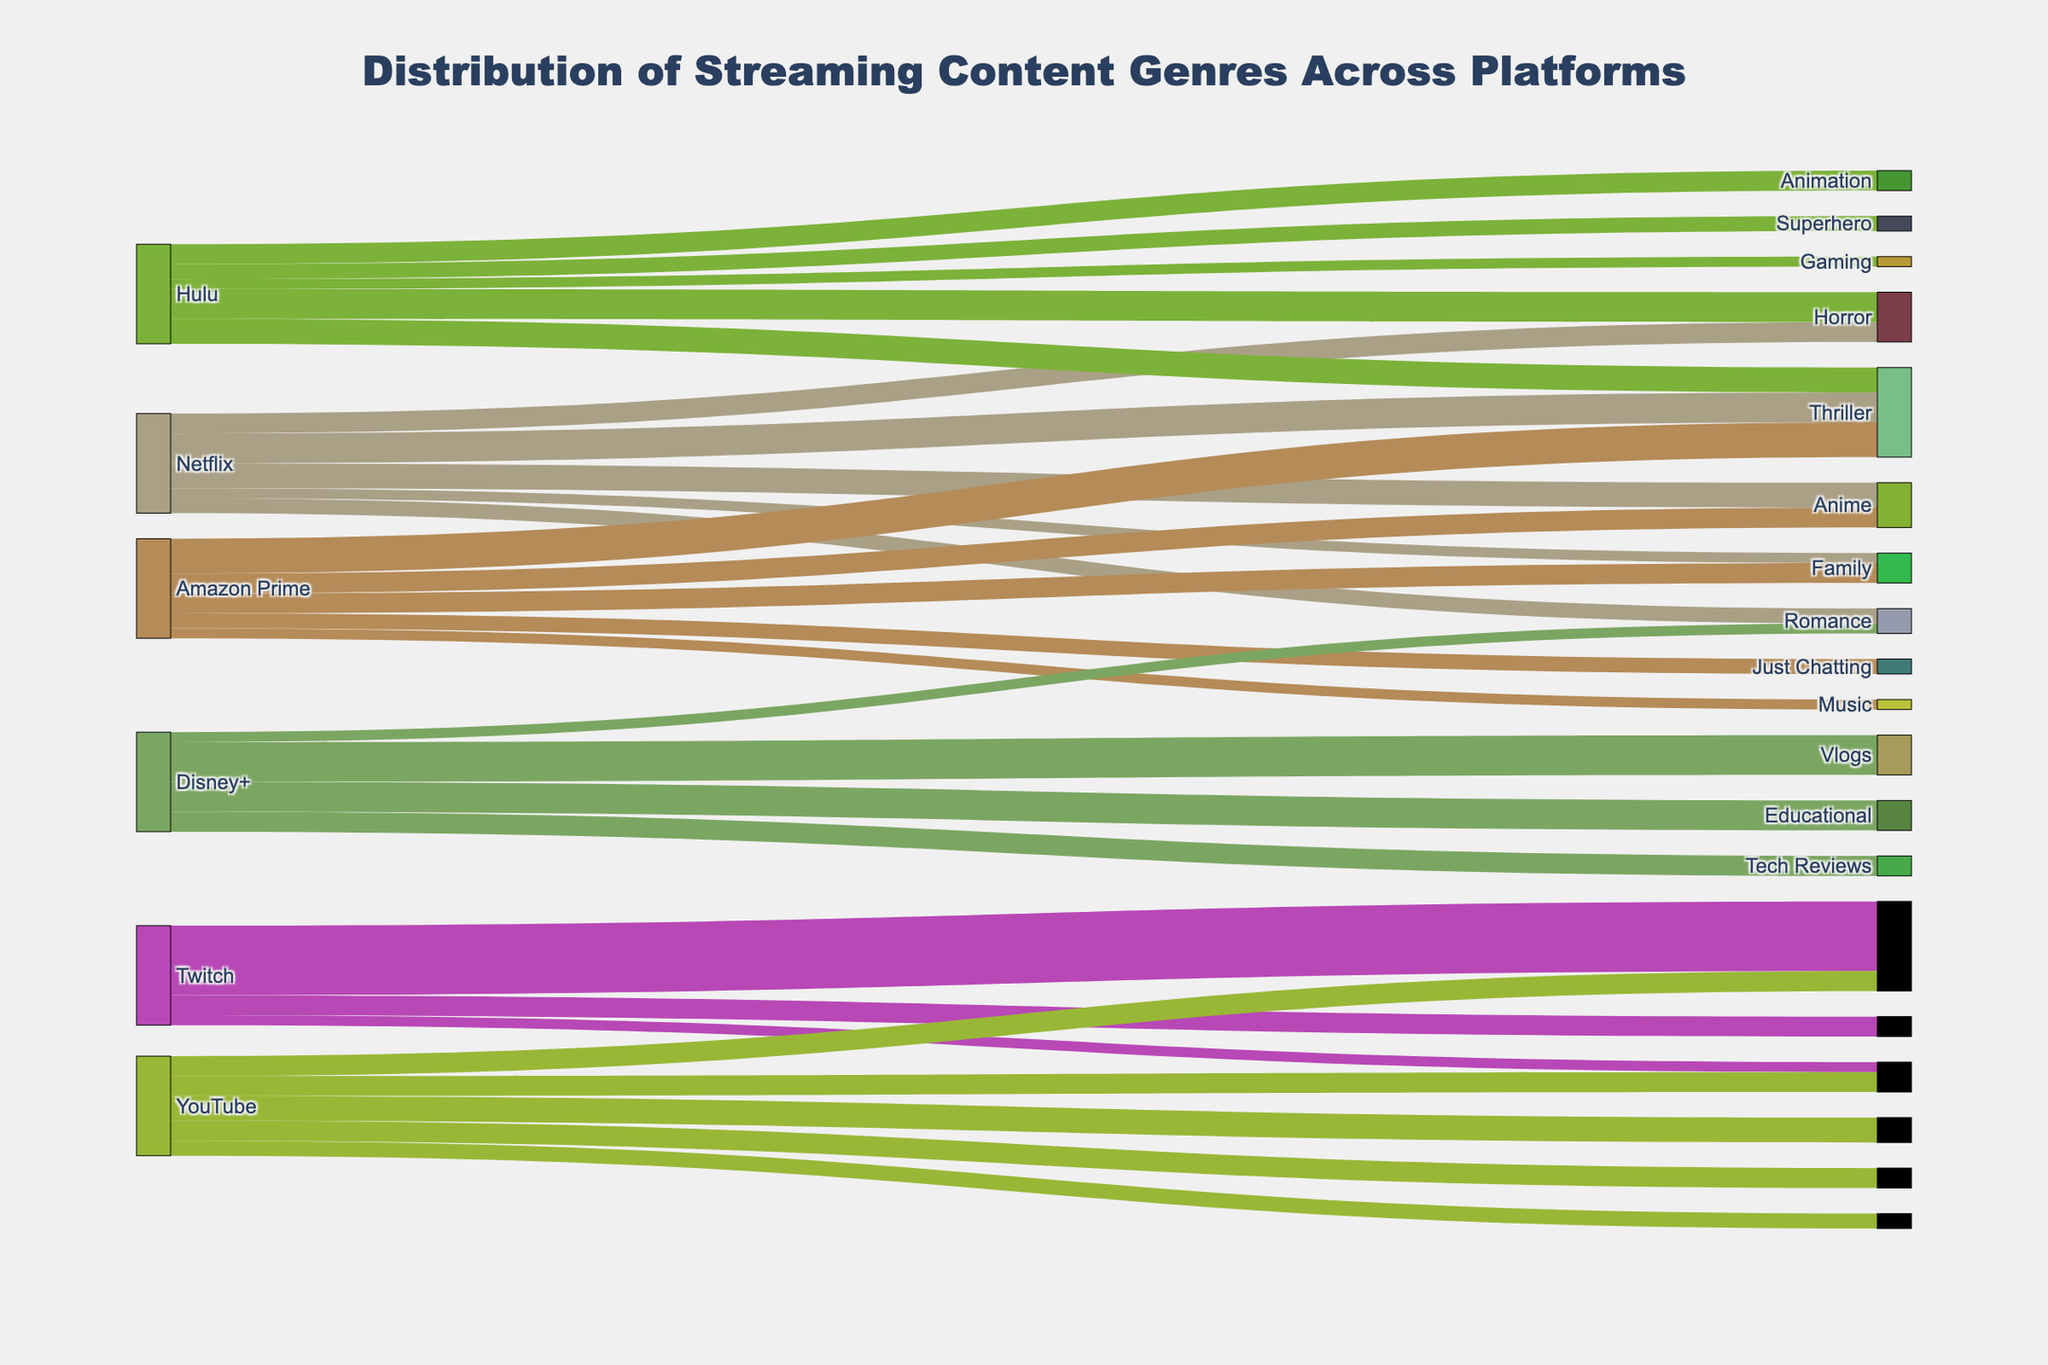what is the title of the figure? The title of the figure is usually displayed at the top center of the plot. In this case, you can see it above the Sankey diagram. The title reads "Distribution of Streaming Content Genres Across Platforms".
Answer: Distribution of Streaming Content Genres Across Platforms Which platform has the largest percentage of content in a single genre? Look at the Sankey diagram and find the widest link from any platform to a genre. The widest link indicates the highest percentage. The platform with the largest percentage of content in a single genre is Twitch with 70% Gaming.
Answer: Twitch What is the total percentage of Drama content across all platforms? Check each platform and sum the percentages of Drama content. Netflix has 30%, Hulu has 25%, and Amazon Prime has 35%. Adding them together: 30 + 25 + 35 = 90%.
Answer: 90% Which genre is exclusive to Hulu among listed platforms? Identify genres that are only connected to Hulu. Reality TV and Anime are exclusively connected to Hulu. These genres do not appear connected to any other platform.
Answer: Reality TV and Anime How many genres does Netflix distribute content for? Count the number of different genres connected to Netflix in the Sankey diagram. Netflix is connected to Action, Comedy, Drama, Documentary, and Sci-Fi. So, there are 5 genres.
Answer: 5 Which platform has the most diverse genre distribution? Count the number of different genres each platform is connected to. Netflix is connected to 5 genres, Hulu to 5, Amazon Prime to 5, Disney+ to 4, Twitch to 3, and YouTube to 5. Since multiple platforms have 5 genres, those with the most unique distribution are Netflix, Hulu, Amazon Prime, and YouTube.
Answer: Netflix, Hulu, Amazon Prime, and YouTube What is the total percentage of content that is Sci-Fi across all platforms? Sum the percentages of Sci-Fi content from platforms connected to Sci-Fi. Netflix has 10%, and Amazon Prime has 20%. Therefore, total Sci-Fi content is 10 + 20 = 30%.
Answer: 30% Which genre does Amazon Prime have the highest percentage of its content in? Look at the links between Amazon Prime and its connected genres. The widest link will show the genre with the highest percentage. Drama has the highest percentage at 35%.
Answer: Drama Compare the percentage of Music content between YouTube and Twitch. Which has a higher percentage? Look at the connections between each platform and the Music genre. YouTube is connected to Music with 20%, and Twitch is connected to Music with 10%. YouTube has a higher percentage.
Answer: YouTube 